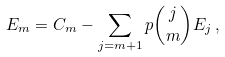Convert formula to latex. <formula><loc_0><loc_0><loc_500><loc_500>E _ { m } = C _ { m } - \sum _ { j = m + 1 } { p } \binom { j } { m } E _ { j } \, ,</formula> 